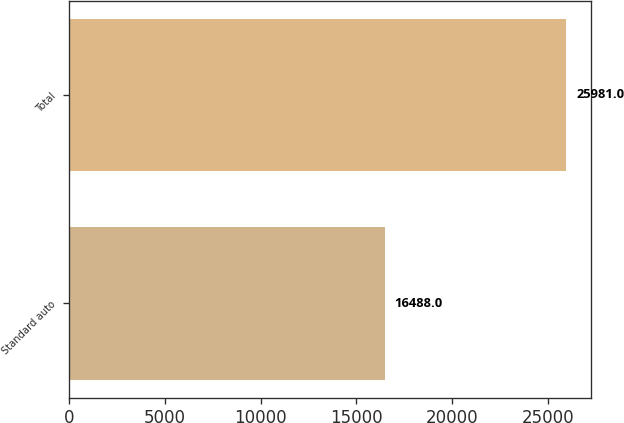Convert chart. <chart><loc_0><loc_0><loc_500><loc_500><bar_chart><fcel>Standard auto<fcel>Total<nl><fcel>16488<fcel>25981<nl></chart> 